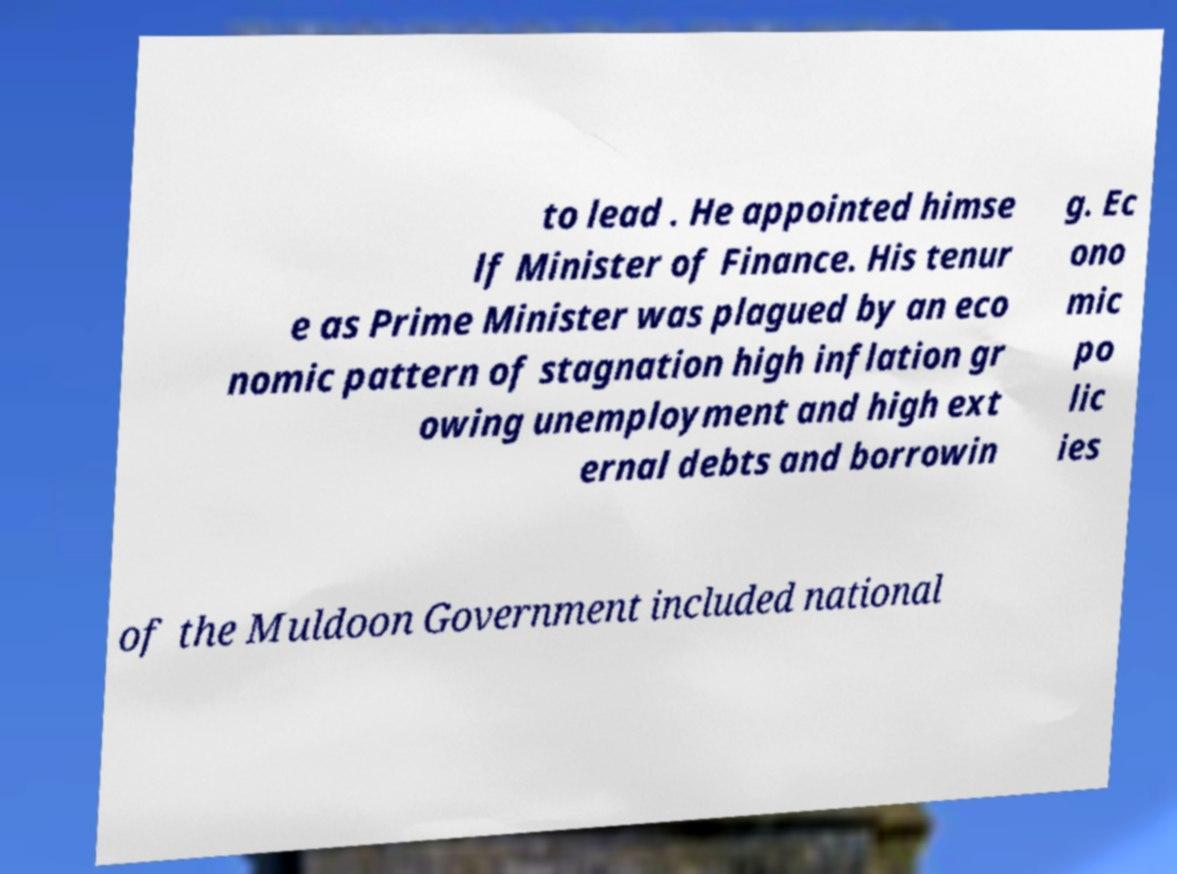Please identify and transcribe the text found in this image. to lead . He appointed himse lf Minister of Finance. His tenur e as Prime Minister was plagued by an eco nomic pattern of stagnation high inflation gr owing unemployment and high ext ernal debts and borrowin g. Ec ono mic po lic ies of the Muldoon Government included national 